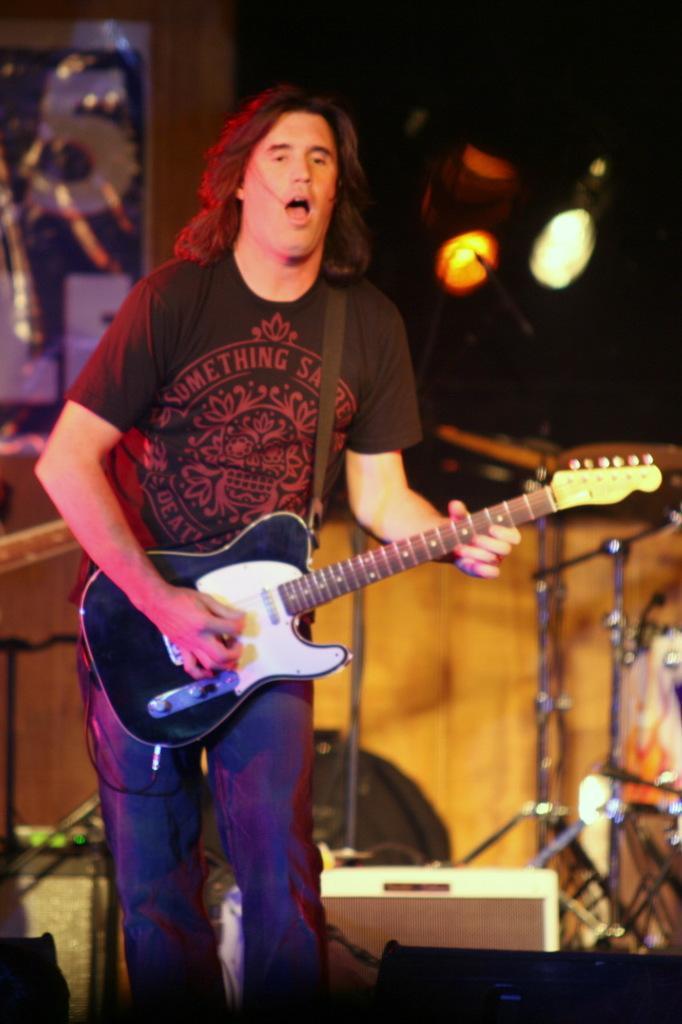Could you give a brief overview of what you see in this image? there is a stage and stage has many instruments are there like mike and guitar and the person he is holding the guitar and he is singing the song he is wearing blue jeans and black t shirt and on the stage there is some lights are there. 